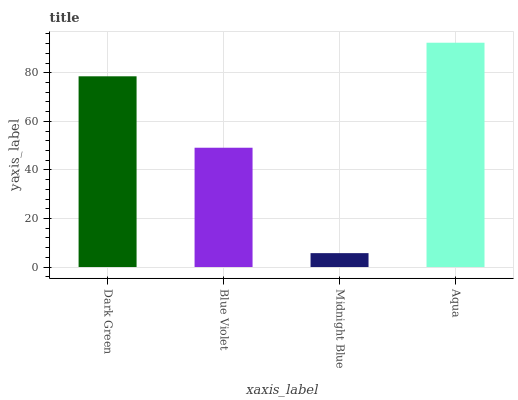Is Midnight Blue the minimum?
Answer yes or no. Yes. Is Aqua the maximum?
Answer yes or no. Yes. Is Blue Violet the minimum?
Answer yes or no. No. Is Blue Violet the maximum?
Answer yes or no. No. Is Dark Green greater than Blue Violet?
Answer yes or no. Yes. Is Blue Violet less than Dark Green?
Answer yes or no. Yes. Is Blue Violet greater than Dark Green?
Answer yes or no. No. Is Dark Green less than Blue Violet?
Answer yes or no. No. Is Dark Green the high median?
Answer yes or no. Yes. Is Blue Violet the low median?
Answer yes or no. Yes. Is Blue Violet the high median?
Answer yes or no. No. Is Dark Green the low median?
Answer yes or no. No. 